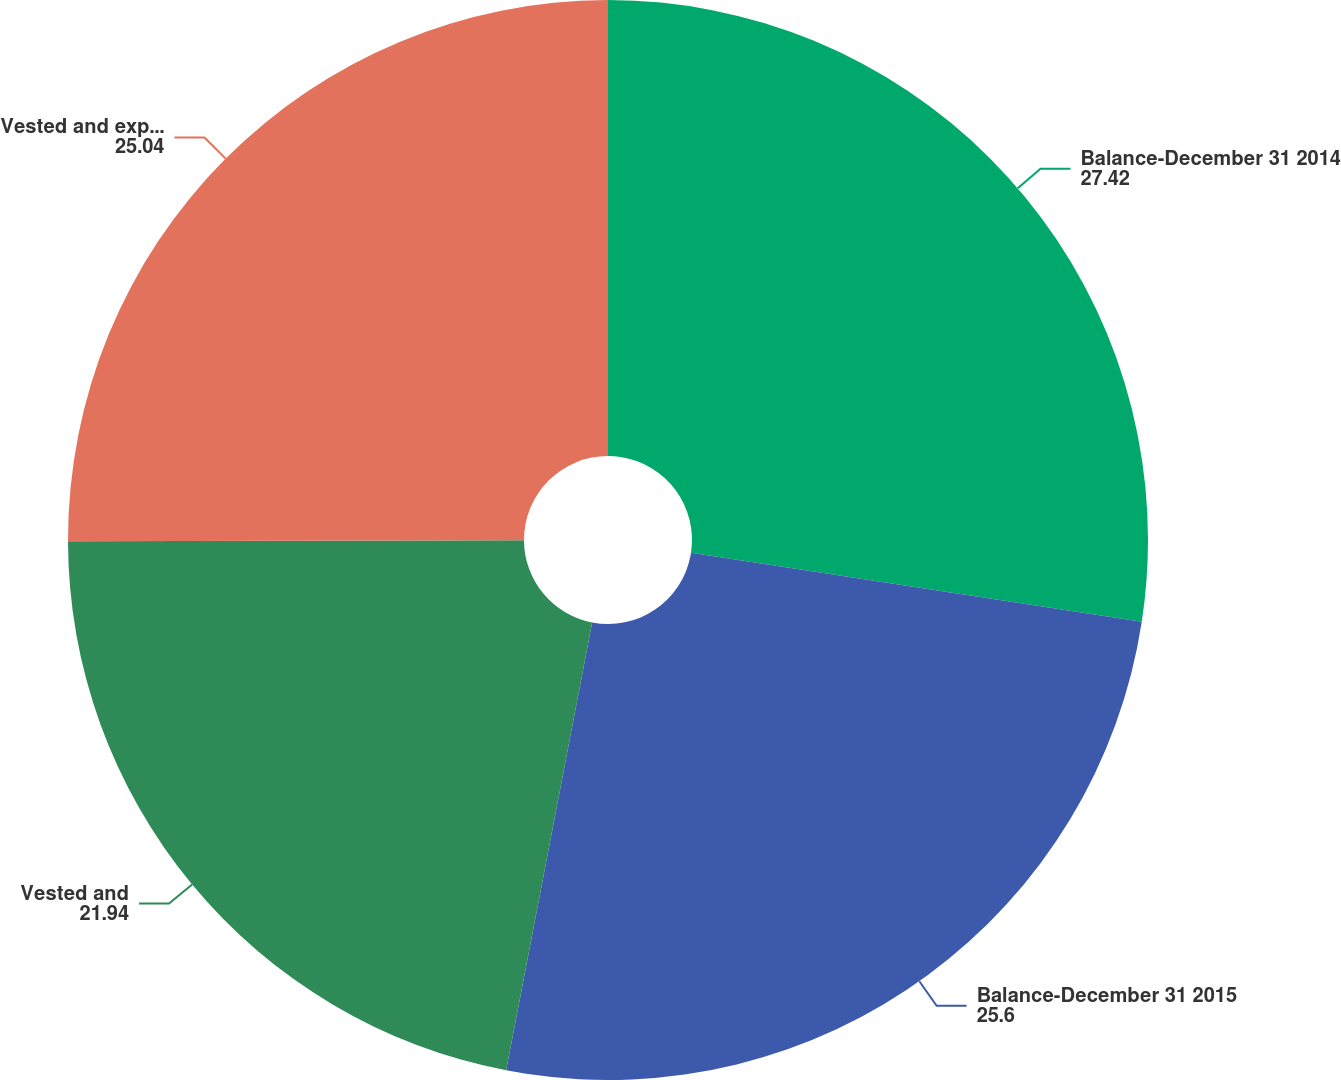<chart> <loc_0><loc_0><loc_500><loc_500><pie_chart><fcel>Balance-December 31 2014<fcel>Balance-December 31 2015<fcel>Vested and<fcel>Vested and expected to<nl><fcel>27.42%<fcel>25.6%<fcel>21.94%<fcel>25.04%<nl></chart> 